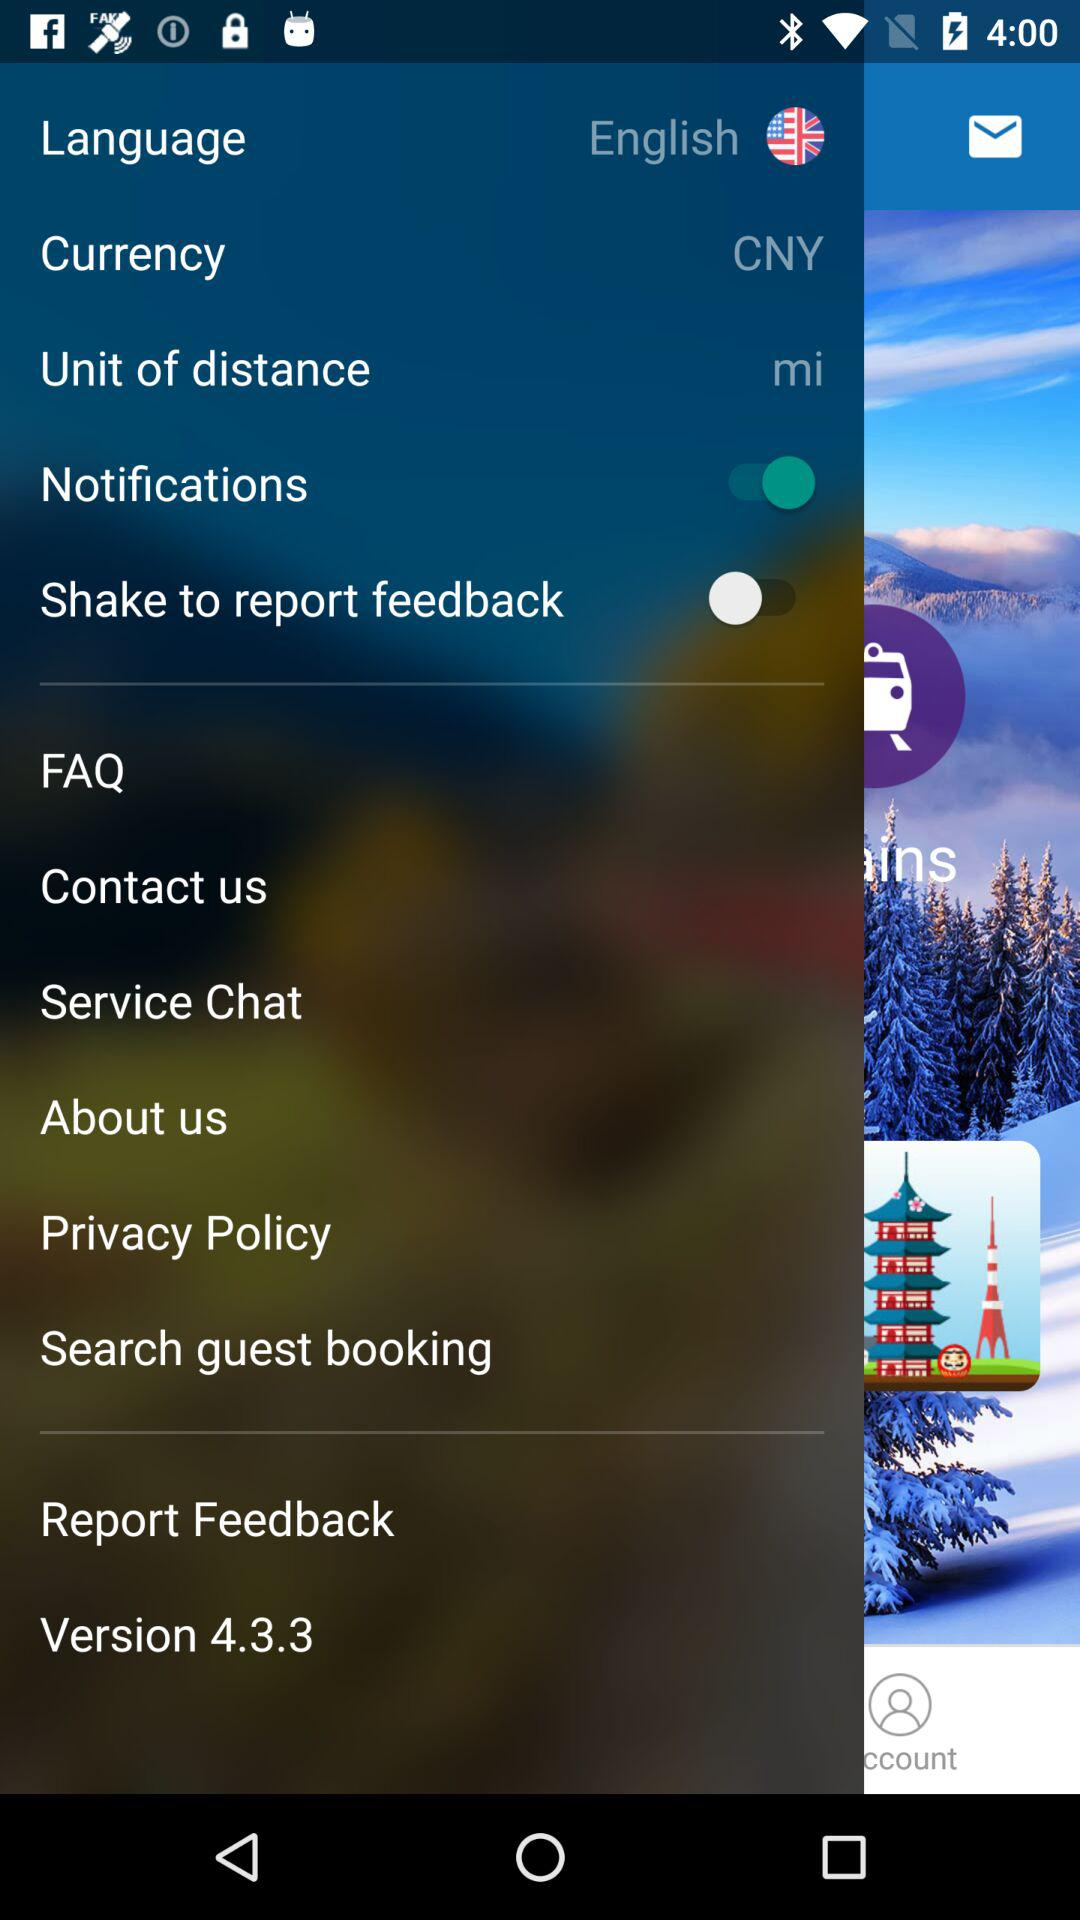What is the language? The language is English. 